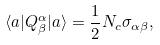Convert formula to latex. <formula><loc_0><loc_0><loc_500><loc_500>\langle a | Q ^ { \alpha } _ { \beta } | a \rangle = \frac { 1 } { 2 } N _ { c } \sigma _ { \alpha \beta } ,</formula> 